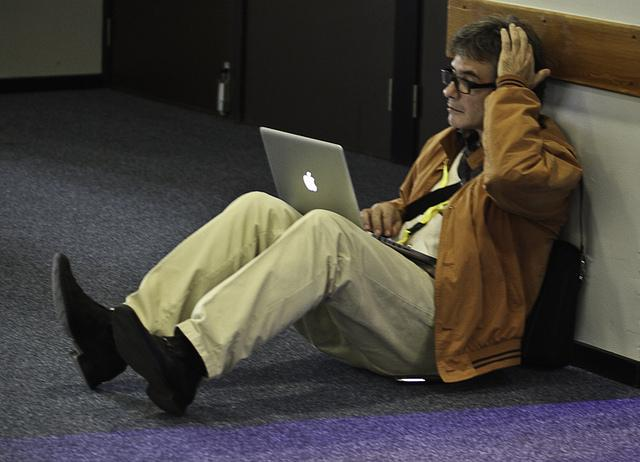Why is this man sitting down? working 